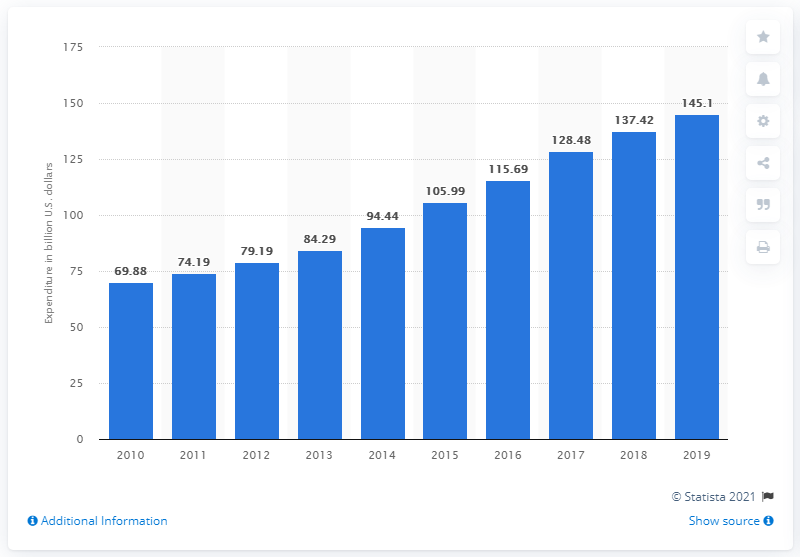Draw attention to some important aspects in this diagram. In 2019, the amount of domestic tourism spending in Southeast Asia was 145.1 billion U.S. dollars. In 2010, the domestic tourism spending in Southeast Asia was 69.88. 